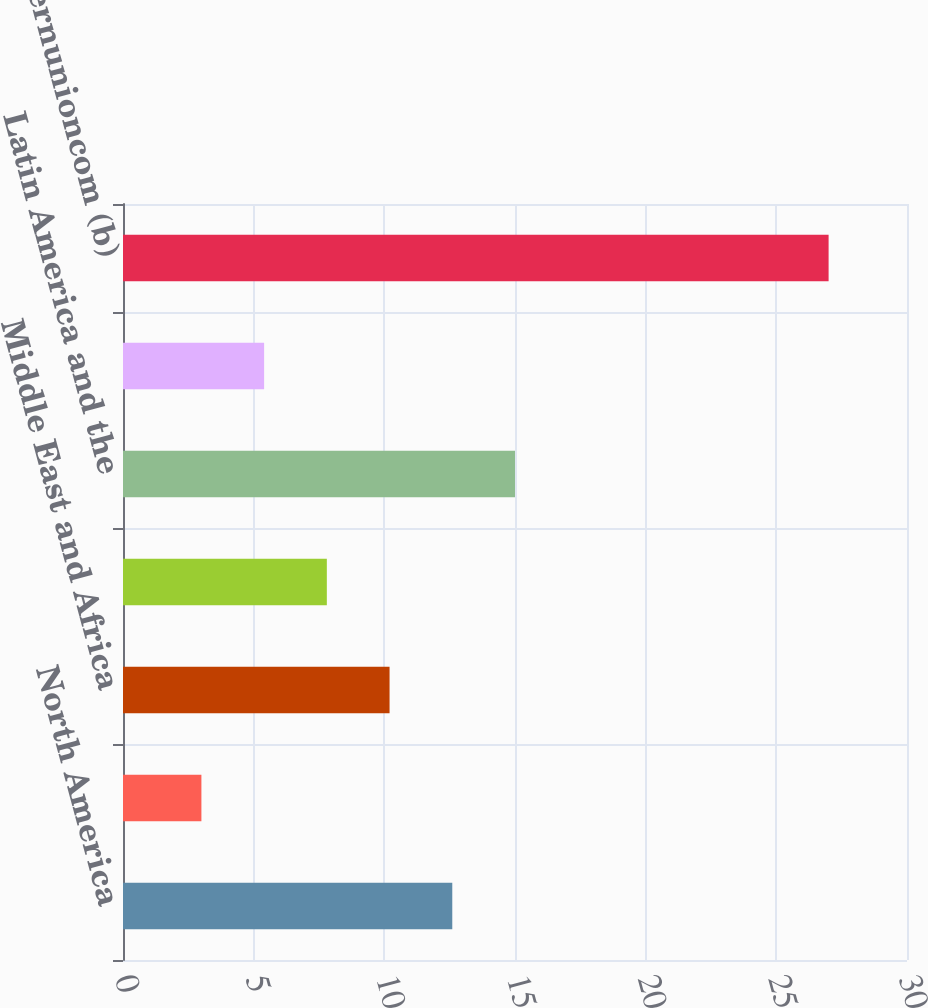Convert chart to OTSL. <chart><loc_0><loc_0><loc_500><loc_500><bar_chart><fcel>North America<fcel>Europe and CIS<fcel>Middle East and Africa<fcel>Asia Pacific (APAC)<fcel>Latin America and the<fcel>Total Consumer-to-Consumer<fcel>westernunioncom (b)<nl><fcel>12.6<fcel>3<fcel>10.2<fcel>7.8<fcel>15<fcel>5.4<fcel>27<nl></chart> 